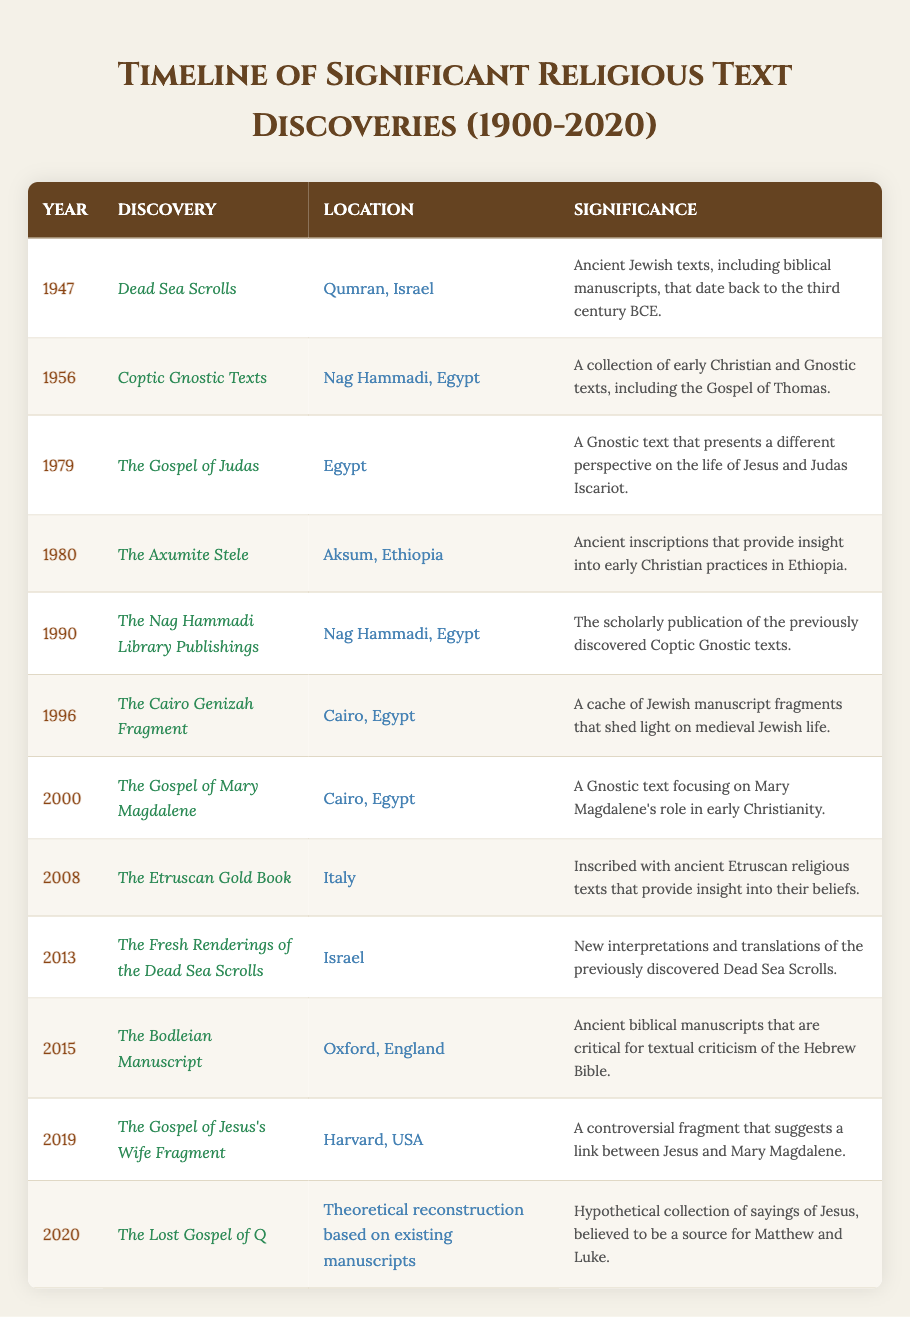What year were the Dead Sea Scrolls discovered? The table shows that the Dead Sea Scrolls were discovered in the year 1947.
Answer: 1947 What is the significance of the Coptic Gnostic Texts? According to the table, the Coptic Gnostic Texts are significant because they are a collection of early Christian and Gnostic texts, including the Gospel of Thomas.
Answer: Early Christian and Gnostic texts Where were the Etruscan Gold Book religious texts found? The table indicates that the Etruscan Gold Book was discovered in Italy.
Answer: Italy Which discovery occurred in 2013? The table lists "The Fresh Renderings of the Dead Sea Scrolls" as the discovery that occurred in 2013.
Answer: The Fresh Renderings of the Dead Sea Scrolls Is it true that the Gospel of Judas offers a different perspective on Jesus? Yes, the table confirms that the Gospel of Judas presents a different perspective on the life of Jesus and Judas Iscariot.
Answer: Yes How many discoveries were made in Egypt? To find this, we can count the entries in the table for Egypt, which are the Coptic Gnostic Texts, The Gospel of Judas, The Cairo Genizah Fragment, The Gospel of Mary Magdalene, and the Gospel of Jesus's Wife Fragment. This totals to 5 discoveries.
Answer: 5 What is the significance of the Bodleian Manuscript? The Bodleian Manuscript is significant according to the table because it is made up of ancient biblical manuscripts that are critical for textual criticism of the Hebrew Bible.
Answer: Critical for textual criticism Which year had the most recent discovery listed? The most recent discovery listed in the table is in the year 2020, which is "The Lost Gospel of Q."
Answer: 2020 What geographical location appears the most in this table? By analyzing the entries, Egypt appears 5 times; no other location has as many entries, making it the most frequent.
Answer: Egypt Which discoveries relate to early Christian practices? The discoveries related to early Christian practices include the Coptic Gnostic Texts, The Axumite Stele, and The Gospel of Mary Magdalene based on their significance described in the table.
Answer: Coptic Gnostic Texts, The Axumite Stele, The Gospel of Mary Magdalene 